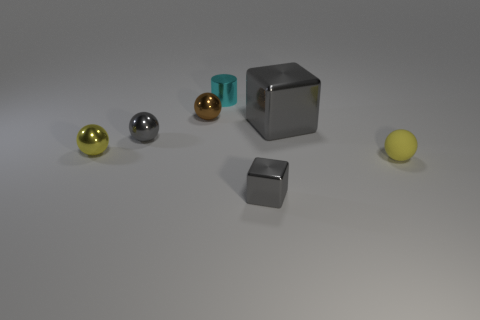There is a metal thing that is the same color as the small rubber thing; what shape is it?
Your answer should be very brief. Sphere. There is a yellow object that is on the left side of the small yellow matte object; what is its size?
Give a very brief answer. Small. There is a cube that is the same size as the metal cylinder; what color is it?
Your answer should be very brief. Gray. Are there any metallic cylinders that have the same color as the large shiny thing?
Offer a terse response. No. Are there fewer metal cubes that are on the right side of the yellow metal ball than shiny spheres that are behind the large metallic thing?
Offer a very short reply. No. What material is the thing that is both right of the small brown sphere and to the left of the small gray metal block?
Provide a succinct answer. Metal. Do the cyan thing and the tiny metal object that is in front of the yellow shiny ball have the same shape?
Your answer should be compact. No. What number of other objects are the same size as the yellow metallic ball?
Keep it short and to the point. 5. Is the number of large gray shiny blocks greater than the number of spheres?
Your answer should be compact. No. How many small spheres are both in front of the large gray thing and to the left of the large gray metallic thing?
Your answer should be compact. 2. 